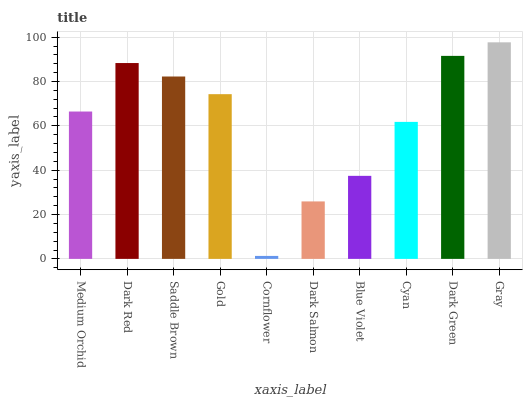Is Cornflower the minimum?
Answer yes or no. Yes. Is Gray the maximum?
Answer yes or no. Yes. Is Dark Red the minimum?
Answer yes or no. No. Is Dark Red the maximum?
Answer yes or no. No. Is Dark Red greater than Medium Orchid?
Answer yes or no. Yes. Is Medium Orchid less than Dark Red?
Answer yes or no. Yes. Is Medium Orchid greater than Dark Red?
Answer yes or no. No. Is Dark Red less than Medium Orchid?
Answer yes or no. No. Is Gold the high median?
Answer yes or no. Yes. Is Medium Orchid the low median?
Answer yes or no. Yes. Is Cyan the high median?
Answer yes or no. No. Is Gray the low median?
Answer yes or no. No. 